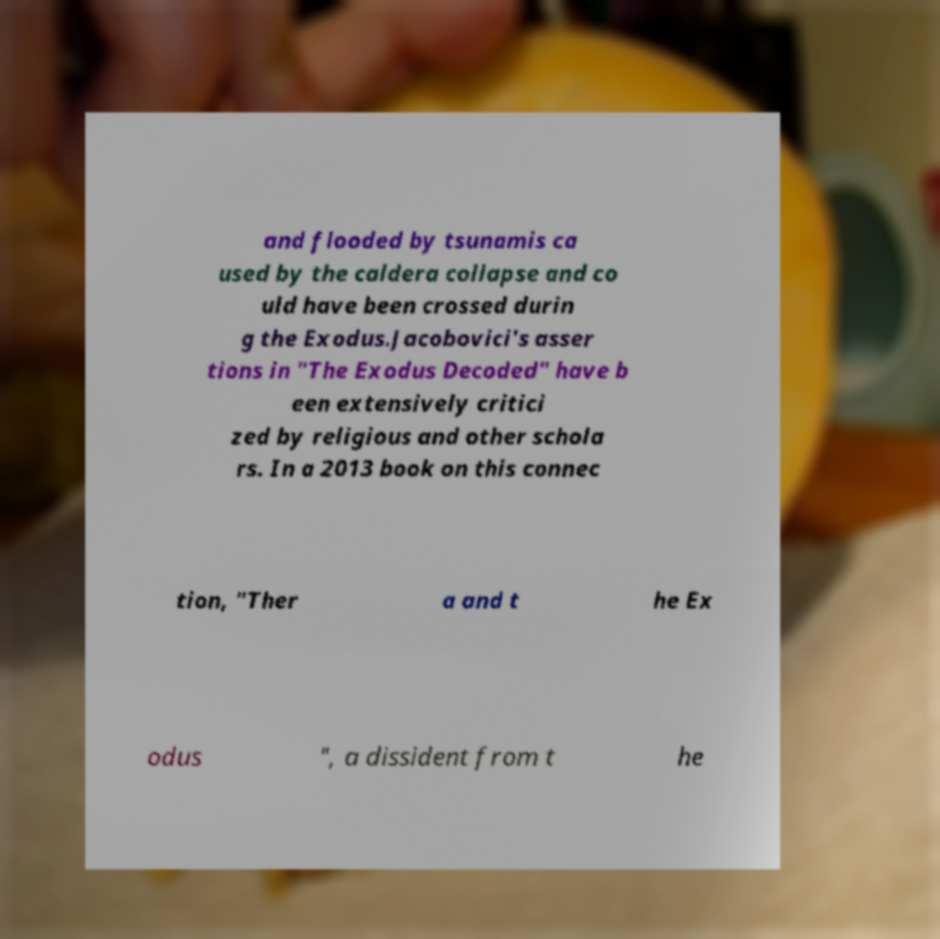There's text embedded in this image that I need extracted. Can you transcribe it verbatim? and flooded by tsunamis ca used by the caldera collapse and co uld have been crossed durin g the Exodus.Jacobovici's asser tions in "The Exodus Decoded" have b een extensively critici zed by religious and other schola rs. In a 2013 book on this connec tion, "Ther a and t he Ex odus ", a dissident from t he 